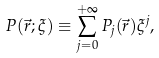<formula> <loc_0><loc_0><loc_500><loc_500>P ( { \vec { r } } ; \xi ) \equiv \sum _ { j = 0 } ^ { + \infty } P _ { j } ( { \vec { r } } ) \xi ^ { j } ,</formula> 